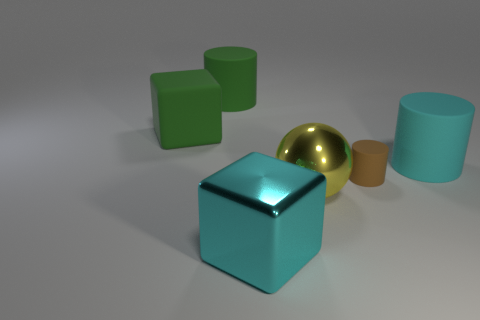Add 1 cylinders. How many objects exist? 7 Subtract all balls. How many objects are left? 5 Add 1 large yellow shiny balls. How many large yellow shiny balls exist? 2 Subtract 0 yellow cubes. How many objects are left? 6 Subtract all large green shiny cylinders. Subtract all large cyan cylinders. How many objects are left? 5 Add 5 large cyan metal things. How many large cyan metal things are left? 6 